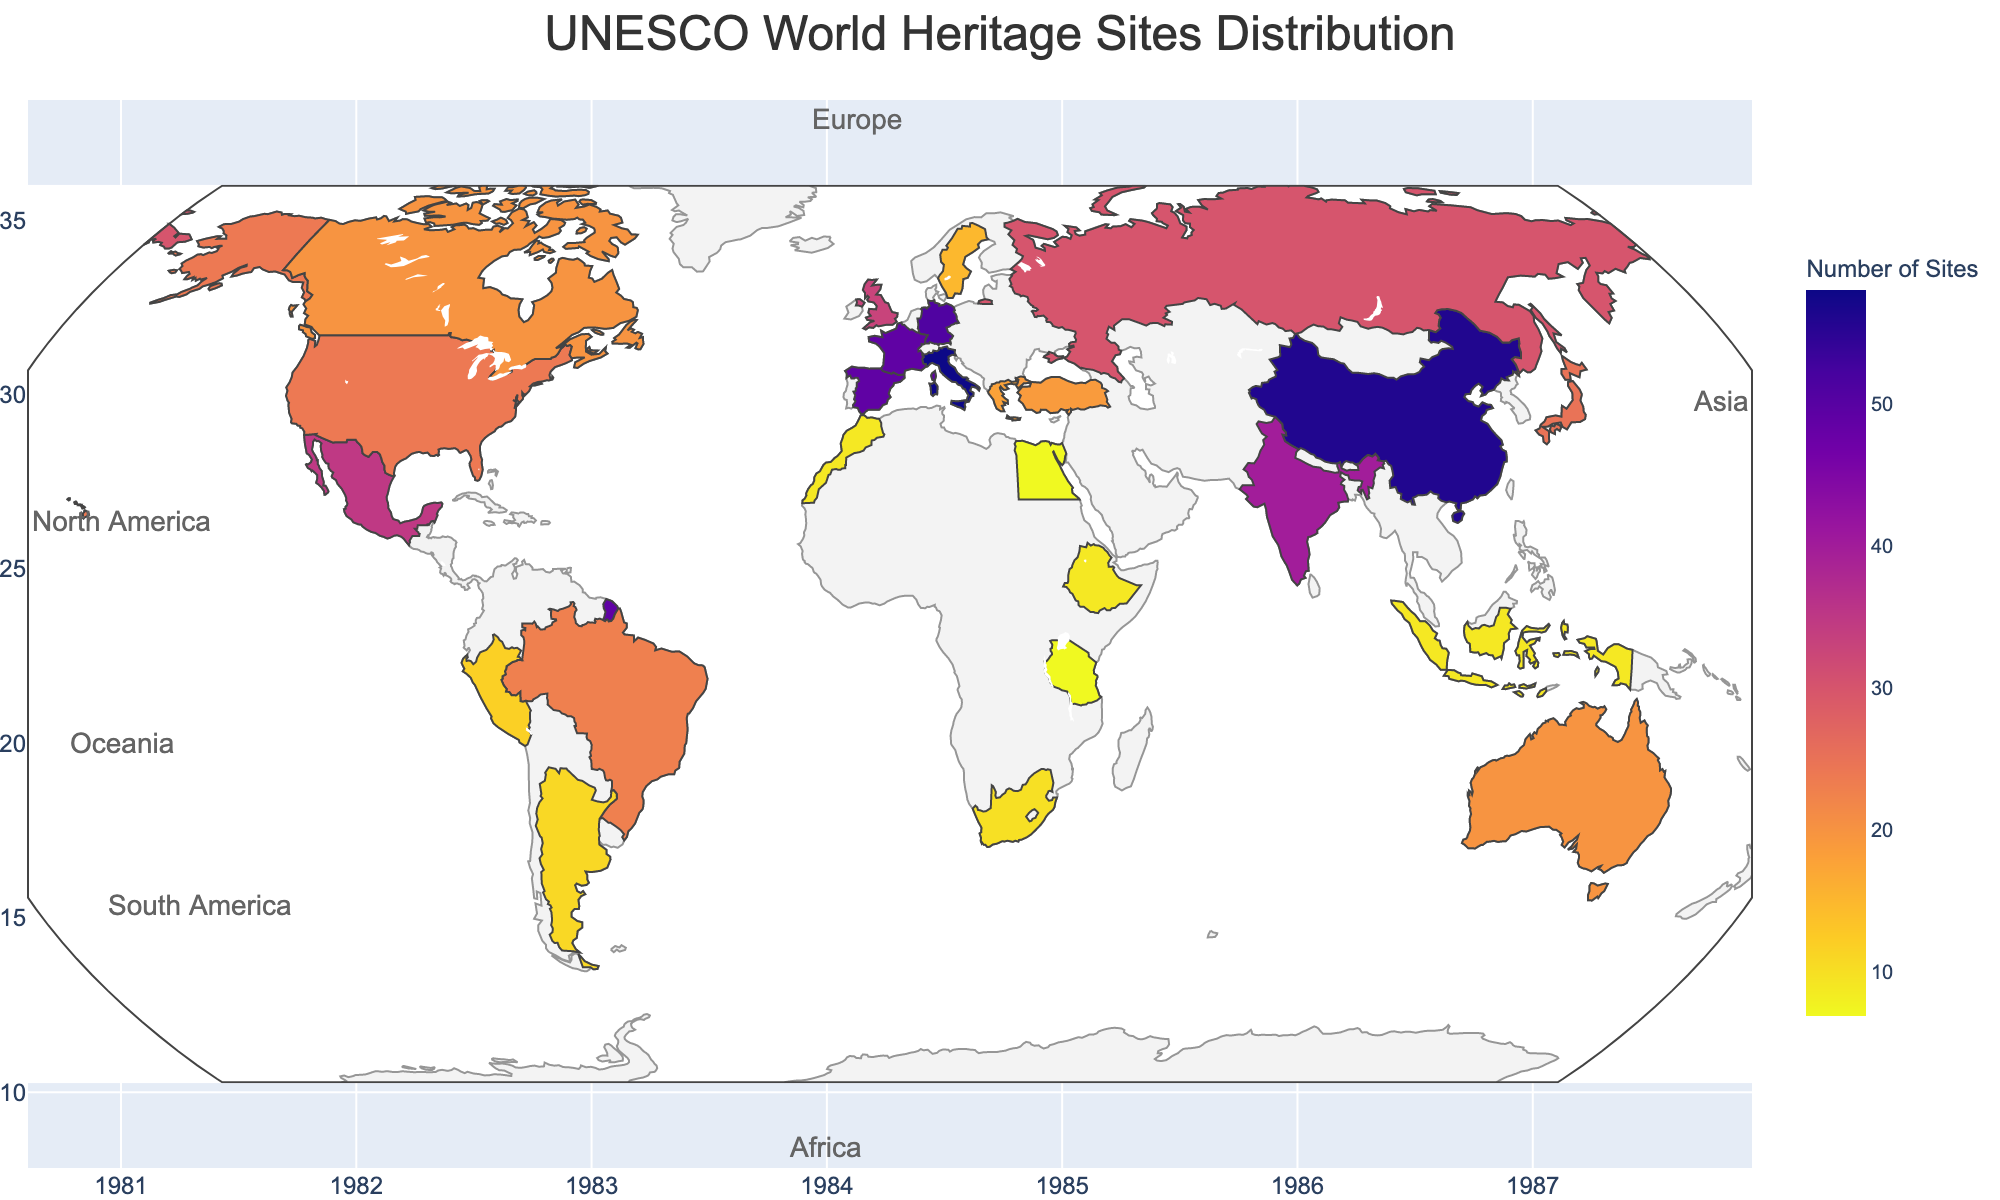How many countries are shown to have UNESCO World Heritage Sites? Count the number of unique countries listed across all continents.
Answer: 24 Which country in Asia has the most UNESCO World Heritage Sites? Look at the data for Asian countries and identify the one with the highest number of sites.
Answer: China When was the first site inscribed in the United States? Refer to the "Year_First_Inscribed" for the United States.
Answer: 1978 How many sites are there in total across all African countries? Add the number of sites from Egypt, South Africa, Morocco, Tanzania, and Ethiopia. The sum is 7 + 10 + 9 + 7 + 9.
Answer: 42 Which European country has the least number of UNESCO World Heritage Sites, and how many does it have? Look at the number of sites in European countries and find the minimum value; Sweden has 15 sites.
Answer: Sweden, 15 Is there a correlation between the year a country's first site was inscribed and the number of sites it has? This is a complex question requiring multiple observations. Generally, earlier inscriptions might suggest more sites over time but not always. For example, Germany (51 sites, first in 1978) vs. Russia (30 sites, first in 1990).
Answer: No clear correlation Which continent has the highest average number of sites per country? Calculate the average number of sites for countries in each continent: Europe (268/8), Asia (149/5), North America (79/3), South America (46/3), Africa (42/5), Oceania (20/1).
Answer: Europe How is the data color-coded on the map? The map uses a color scale transitioning (likely from light to dark) to represent the number of sites where darker colors indicate more sites.
Answer: Color scale If a country has more than 40 sites, which continent is it most likely located in? Countries with more than 40 sites are Italy, China, Germany, Spain, France, and India. These are located in Europe and Asia.
Answer: Europe or Asia Which country was the first to have a UNESCO World Heritage Site inscribed, and how many sites does it have now? Identify the earliest "Year_First_Inscribed," which is 1978 for Germany and the United States. Germany has 51 sites.
Answer: Germany, 51 